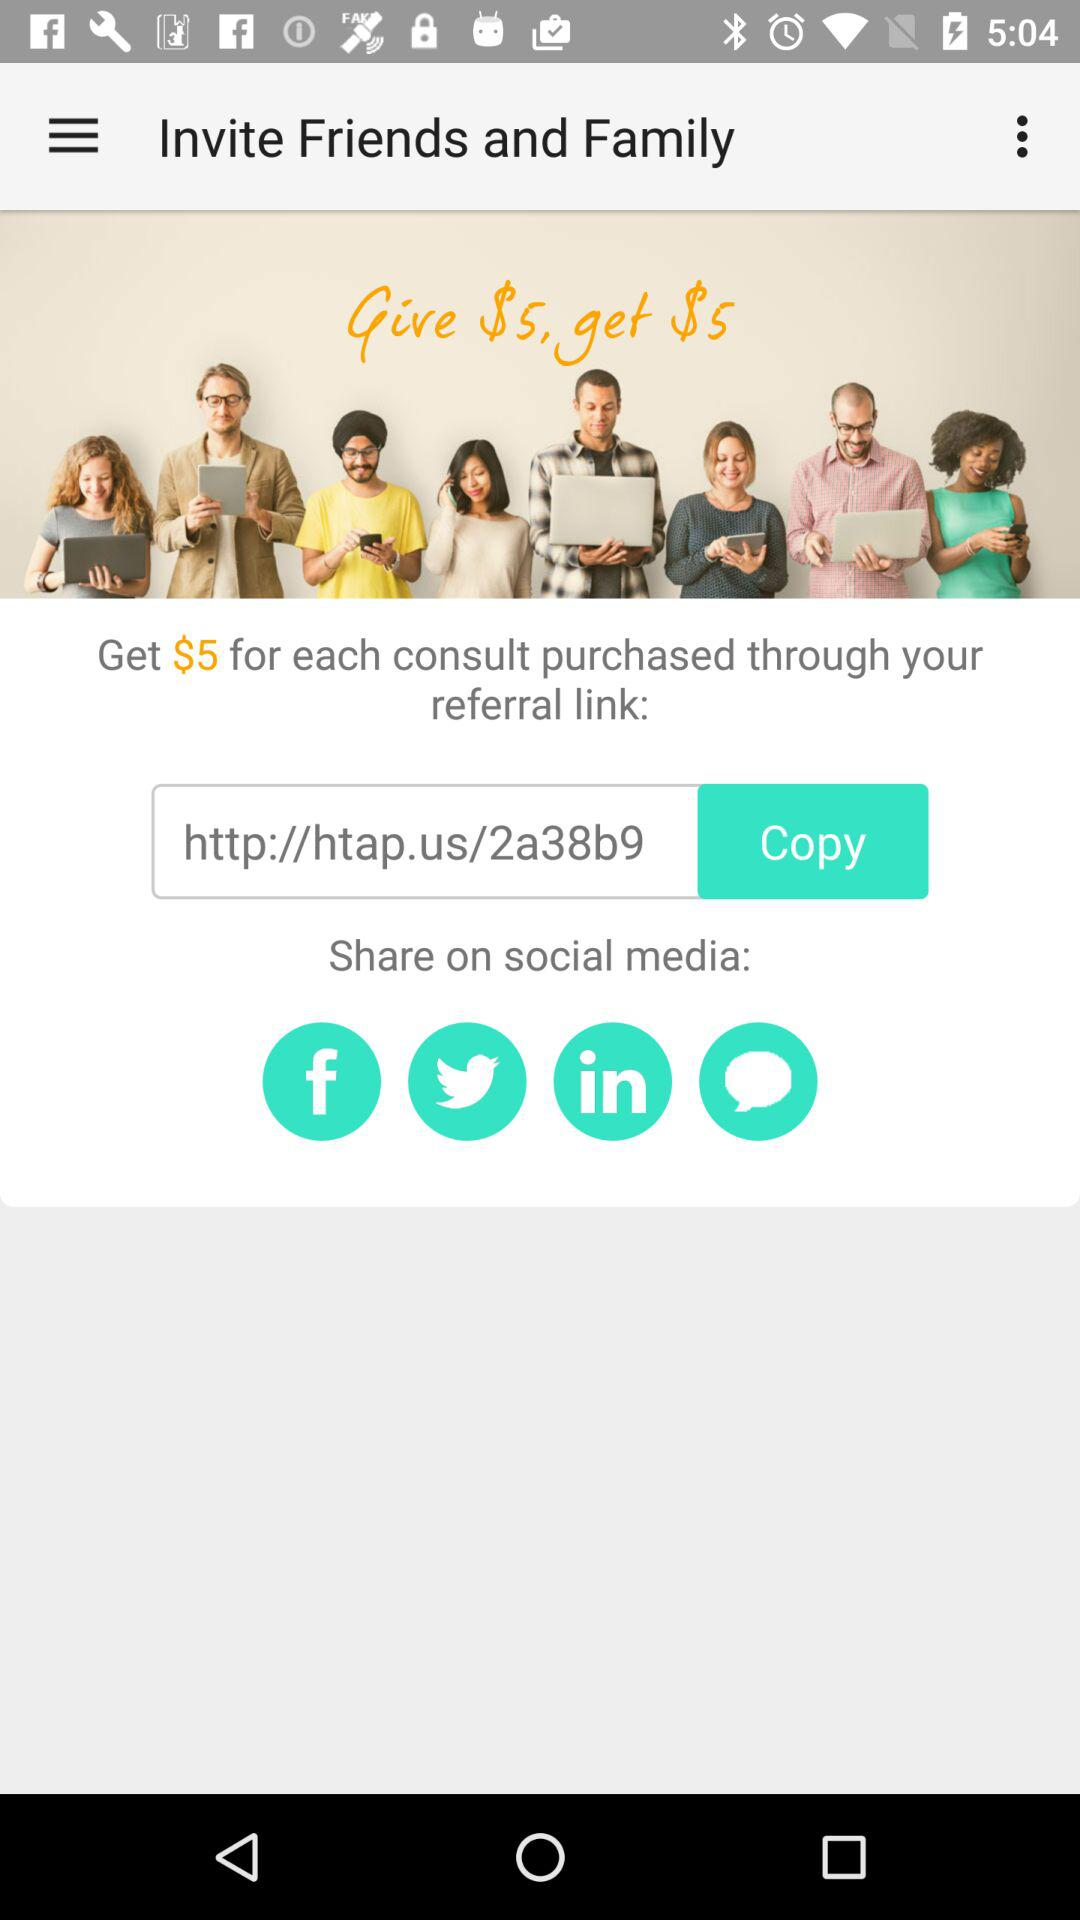How many social media platforms can you share the referral link with?
Answer the question using a single word or phrase. 4 